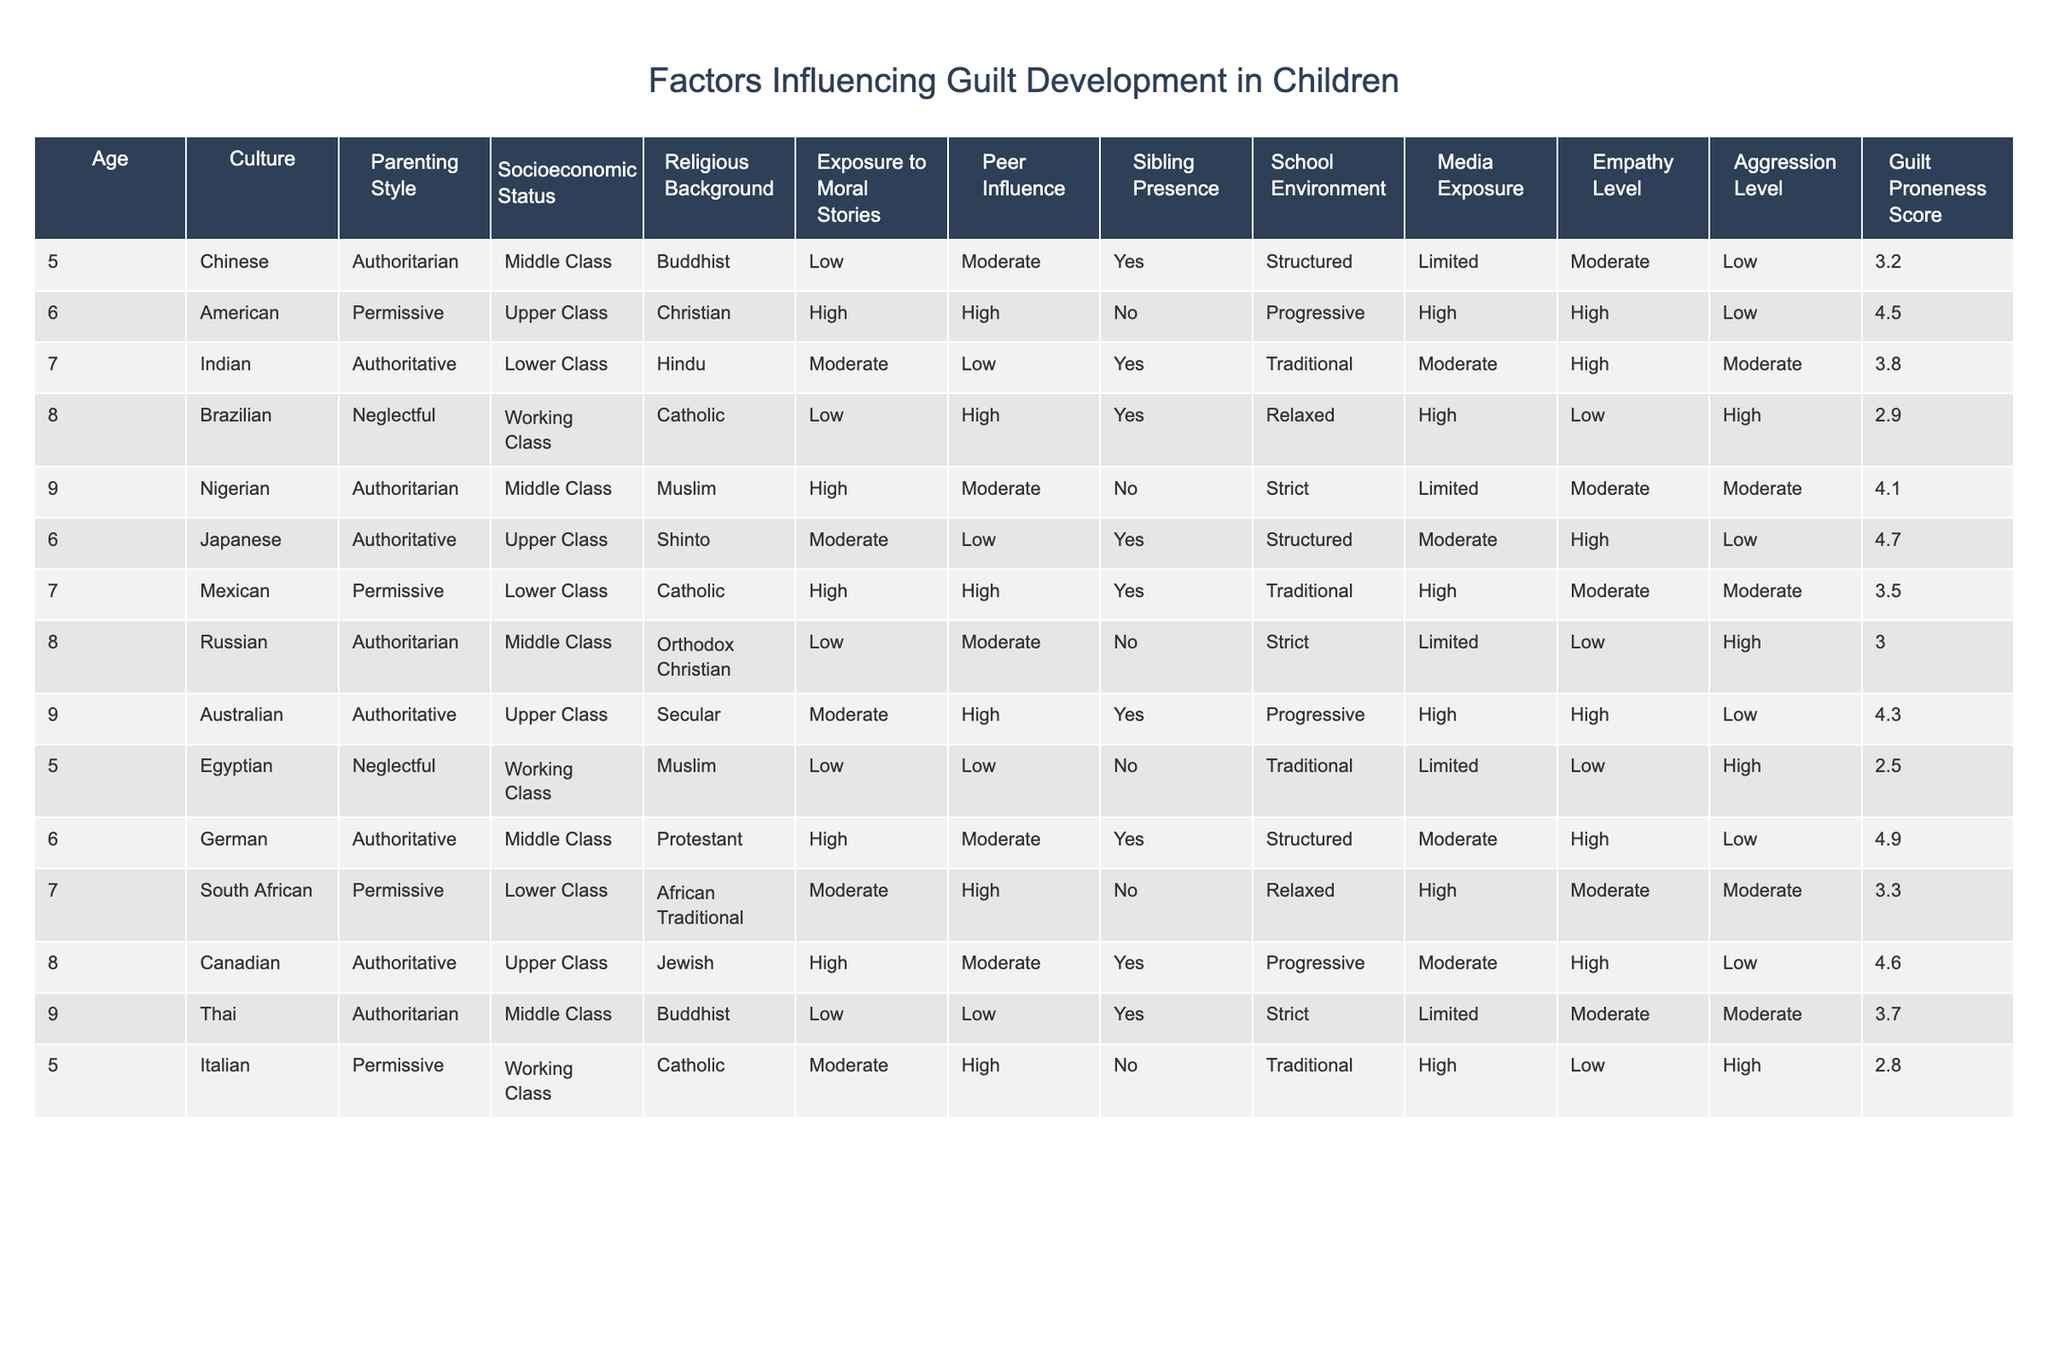What is the Guilt Proneness Score for the Japanese child? The Guilt Proneness Score for the Japanese child, who is 6 years old and has an Authoritative parenting style, can be found directly in the table as 4.7.
Answer: 4.7 Which child has the highest Guilt Proneness Score? By reviewing the Guilt Proneness Scores listed in the table, the highest score is 4.9, which belongs to the German child aged 6 and raised in an Authoritative parenting style.
Answer: 4.9 Is there a relationship between Parenting Style and Guilt Proneness Score? To determine the relationship, I would look at the average Guilt Proneness Scores for each Parenting Style indicated. For Authoritarian, the average is (3.2 + 4.1 + 4.7 + 3.7)/4 = 3.975; for Permissive, it’s (4.5 + 3.5 + 2.8)/3 = 3.6; for Authoritative, it’s (3.8 + 4.7 + 4.3 + 4.6 + 4.9)/5 = 4.506; for Neglectful, it is (2.9 + 2.5)/2 = 2.7. The scores suggest that Authoritative parenting is associated with the highest average Guilt Proneness Score.
Answer: Yes, Authoritative parenting is associated with higher scores What is the average Guilt Proneness Score across all cultures? To find the average Guilt Proneness Score, I would add up all the scores: 3.2 + 4.5 + 3.8 + 2.9 + 4.1 + 4.7 + 3.5 + 3.0 + 4.3 + 2.5 + 4.9 + 3.3 + 4.6 + 2.8 = 51.3. Then divide by the number of entries, which is 14. Therefore, the average is 51.3/14 = 3.664.
Answer: 3.664 Is there a child from an Upper-Class background with a Guilt Proneness Score above 4? Checking the table, I find that the Australian child (aged 9) and the German child (aged 6) are both from Upper-Class backgrounds and their Guilt Proneness Scores are 4.3 and 4.9, respectively, both exceeding 4.
Answer: Yes, there are two children What is the difference in Guilt Proneness Score between the highest and lowest scoring children? The highest Guilt Proneness Score is 4.9 from the German child, while the lowest is 2.5 from the Egyptian child. The difference is calculated as 4.9 - 2.5 = 2.4.
Answer: 2.4 For the children exposed to Moral Stories, what is the total count? To count children exposed to Moral Stories, I review the rows in the table. Those with "High" or "Moderate" exposure (which are considered as yes) are the American, Indian, Japanese, Mexican, Australian, and Canadian children, totaling to 6 children.
Answer: 6 How does Socioeconomic Status appear to affect Guilt Proneness Scores among children? By analyzing the table, you can categorize Socioeconomic Status into three groups: Lower Class, Middle Class, and Upper Class. Calculating the averages: Lower Class = (3.8 + 3.5 + 2.8)/3 = 3.366; Middle Class = (3.2 + 4.1 + 4.7 + 3.0 + 3.3)/5 = 3.426; Upper Class = (4.5 + 4.7 + 4.3 + 4.9)/4 = 4.6. It shows that Upper Class children tend to have higher Guilt Proneness Scores on average.
Answer: Upper Class children have higher scores 